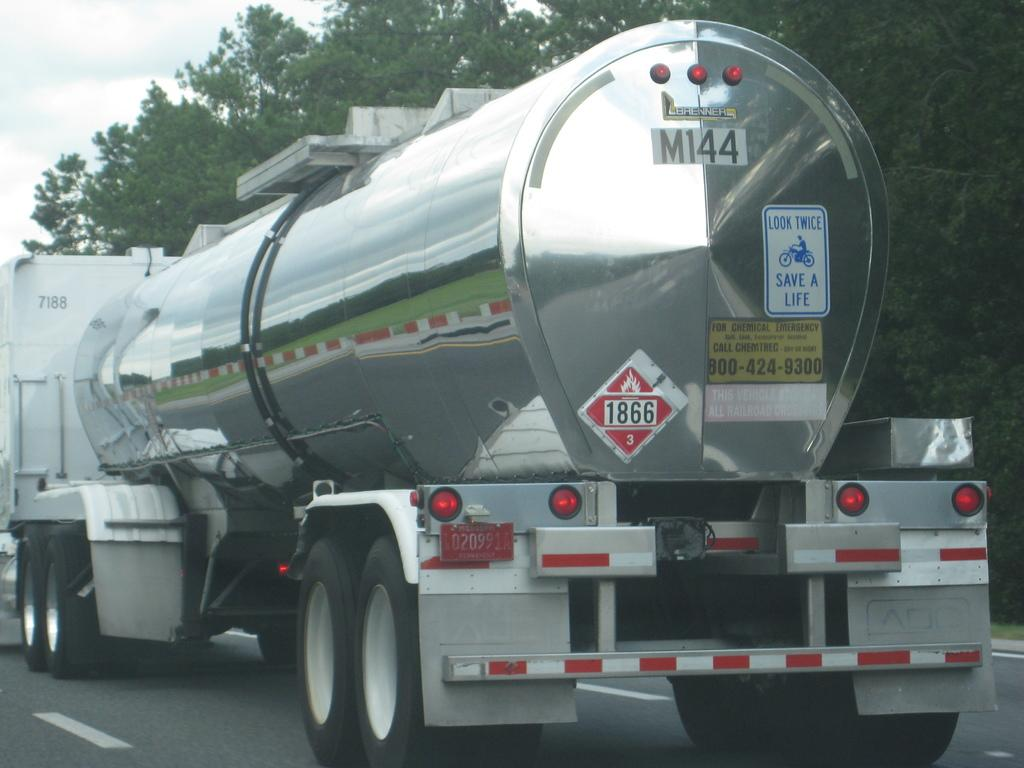What is on the road in the image? There is a vehicle on the road in the image. What else can be seen besides the vehicle? Posters and lights are visible in the image. What can be seen in the background of the image? There are trees and the sky visible in the background of the image. What type of rule is being enforced by the trees in the image? There is no rule being enforced by the trees in the image; they are simply part of the background. 